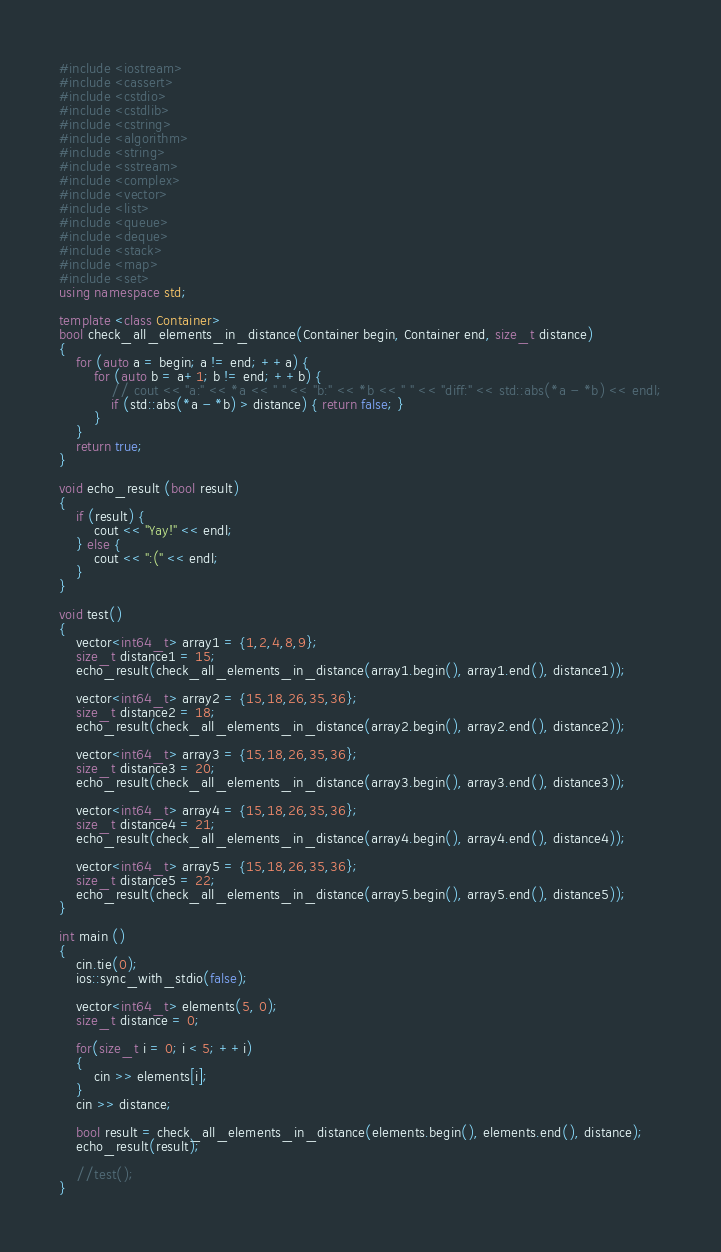<code> <loc_0><loc_0><loc_500><loc_500><_C++_>#include <iostream>
#include <cassert>
#include <cstdio>
#include <cstdlib>
#include <cstring>
#include <algorithm>
#include <string>
#include <sstream>
#include <complex>
#include <vector>
#include <list>
#include <queue>
#include <deque>
#include <stack>
#include <map>
#include <set>
using namespace std;

template <class Container>
bool check_all_elements_in_distance(Container begin, Container end, size_t distance)
{
    for (auto a = begin; a != end; ++a) {
        for (auto b = a+1; b != end; ++b) {
            // cout << "a:" << *a << " " << "b:" << *b << " " << "diff:" << std::abs(*a - *b) << endl;
            if (std::abs(*a - *b) > distance) { return false; }
        }
    }
    return true;
}

void echo_result (bool result)
{
    if (result) {
        cout << "Yay!" << endl;
    } else {
        cout << ":(" << endl;
    }
}

void test()
{
    vector<int64_t> array1 = {1,2,4,8,9};
    size_t distance1 = 15;
    echo_result(check_all_elements_in_distance(array1.begin(), array1.end(), distance1));

    vector<int64_t> array2 = {15,18,26,35,36};
    size_t distance2 = 18;
    echo_result(check_all_elements_in_distance(array2.begin(), array2.end(), distance2));

    vector<int64_t> array3 = {15,18,26,35,36};
    size_t distance3 = 20;
    echo_result(check_all_elements_in_distance(array3.begin(), array3.end(), distance3));

    vector<int64_t> array4 = {15,18,26,35,36};
    size_t distance4 = 21;
    echo_result(check_all_elements_in_distance(array4.begin(), array4.end(), distance4));

    vector<int64_t> array5 = {15,18,26,35,36};
    size_t distance5 = 22;
    echo_result(check_all_elements_in_distance(array5.begin(), array5.end(), distance5));
}

int main ()
{
    cin.tie(0);
    ios::sync_with_stdio(false);

    vector<int64_t> elements(5, 0);
    size_t distance = 0;

    for(size_t i = 0; i < 5; ++i)
    {
        cin >> elements[i];
    }
    cin >> distance;

    bool result = check_all_elements_in_distance(elements.begin(), elements.end(), distance);
    echo_result(result);

    //test();
}
</code> 